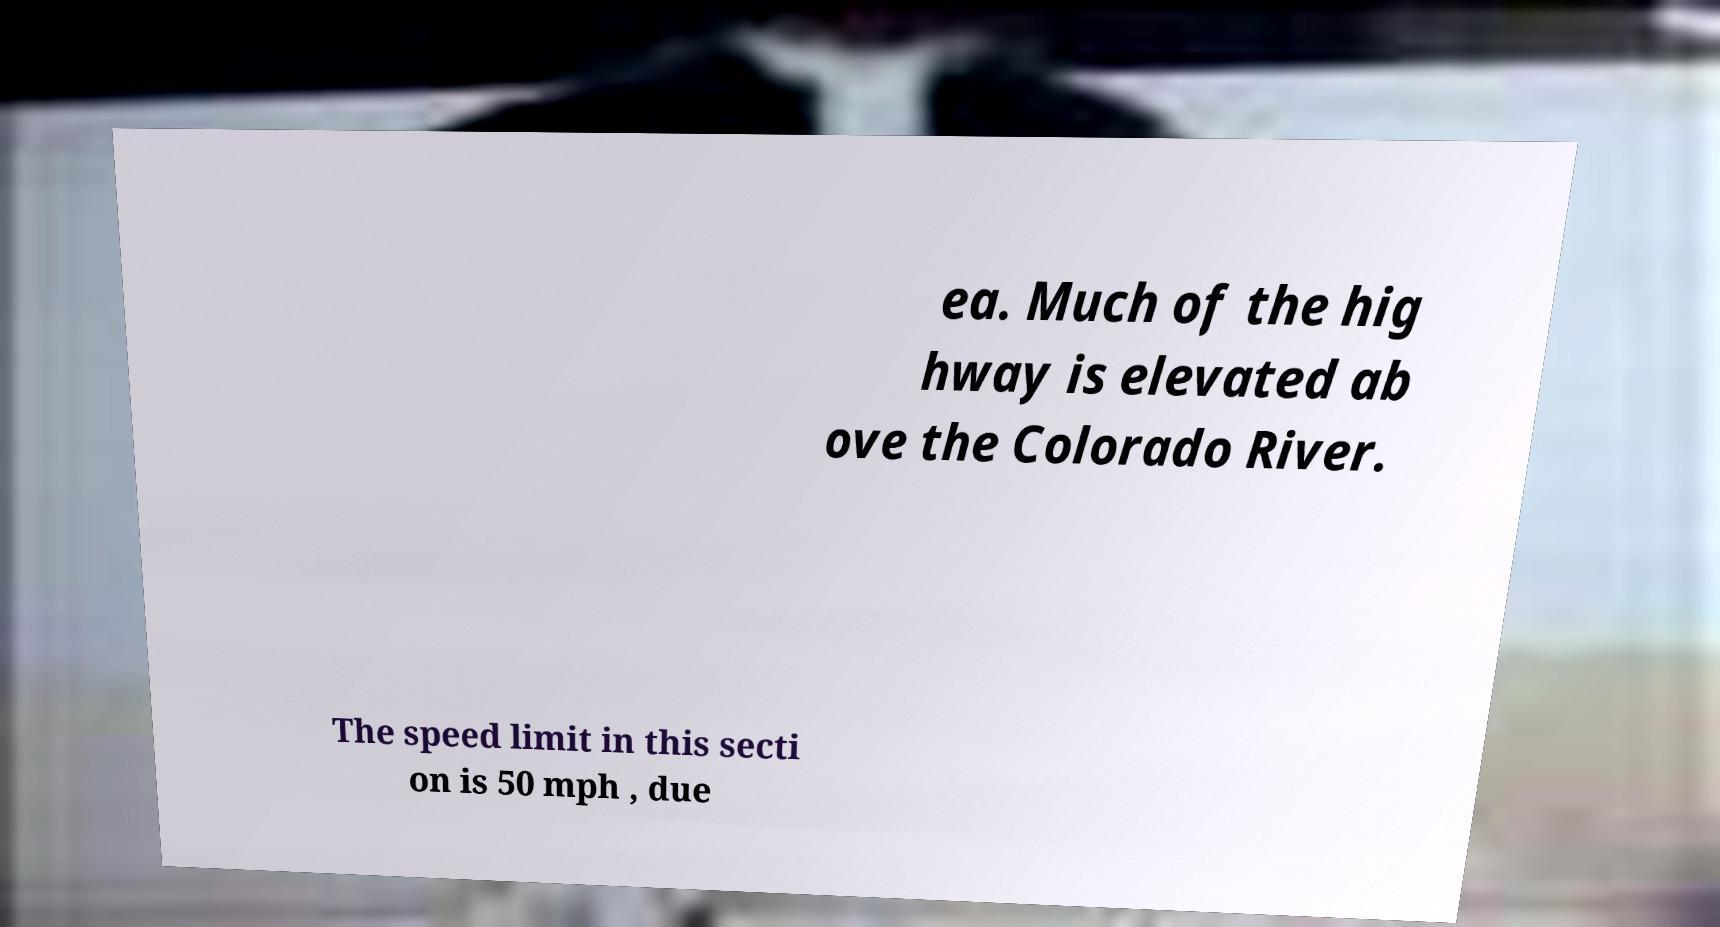I need the written content from this picture converted into text. Can you do that? ea. Much of the hig hway is elevated ab ove the Colorado River. The speed limit in this secti on is 50 mph , due 